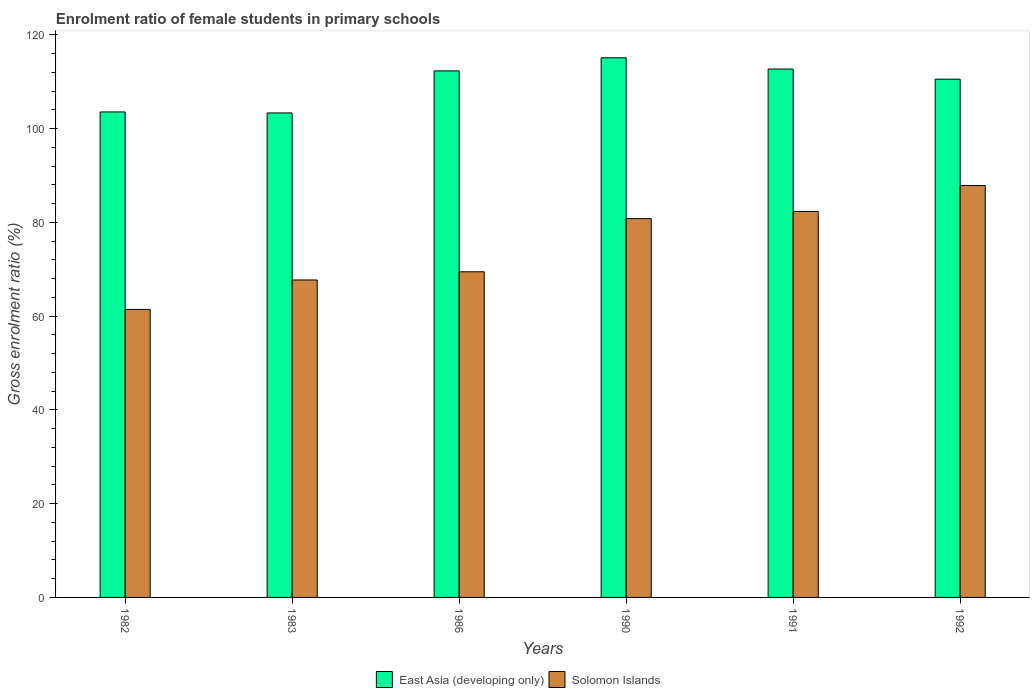How many different coloured bars are there?
Give a very brief answer. 2. How many groups of bars are there?
Make the answer very short. 6. How many bars are there on the 1st tick from the right?
Your response must be concise. 2. What is the label of the 6th group of bars from the left?
Make the answer very short. 1992. In how many cases, is the number of bars for a given year not equal to the number of legend labels?
Ensure brevity in your answer.  0. What is the enrolment ratio of female students in primary schools in East Asia (developing only) in 1992?
Give a very brief answer. 110.53. Across all years, what is the maximum enrolment ratio of female students in primary schools in Solomon Islands?
Provide a short and direct response. 87.85. Across all years, what is the minimum enrolment ratio of female students in primary schools in Solomon Islands?
Provide a short and direct response. 61.43. In which year was the enrolment ratio of female students in primary schools in East Asia (developing only) maximum?
Your answer should be very brief. 1990. In which year was the enrolment ratio of female students in primary schools in Solomon Islands minimum?
Your response must be concise. 1982. What is the total enrolment ratio of female students in primary schools in East Asia (developing only) in the graph?
Keep it short and to the point. 657.49. What is the difference between the enrolment ratio of female students in primary schools in East Asia (developing only) in 1986 and that in 1992?
Offer a terse response. 1.76. What is the difference between the enrolment ratio of female students in primary schools in East Asia (developing only) in 1982 and the enrolment ratio of female students in primary schools in Solomon Islands in 1983?
Ensure brevity in your answer.  35.84. What is the average enrolment ratio of female students in primary schools in East Asia (developing only) per year?
Make the answer very short. 109.58. In the year 1983, what is the difference between the enrolment ratio of female students in primary schools in East Asia (developing only) and enrolment ratio of female students in primary schools in Solomon Islands?
Your answer should be very brief. 35.63. What is the ratio of the enrolment ratio of female students in primary schools in Solomon Islands in 1990 to that in 1991?
Your response must be concise. 0.98. What is the difference between the highest and the second highest enrolment ratio of female students in primary schools in East Asia (developing only)?
Offer a terse response. 2.39. What is the difference between the highest and the lowest enrolment ratio of female students in primary schools in Solomon Islands?
Your answer should be compact. 26.43. In how many years, is the enrolment ratio of female students in primary schools in Solomon Islands greater than the average enrolment ratio of female students in primary schools in Solomon Islands taken over all years?
Your answer should be compact. 3. Is the sum of the enrolment ratio of female students in primary schools in Solomon Islands in 1982 and 1983 greater than the maximum enrolment ratio of female students in primary schools in East Asia (developing only) across all years?
Your answer should be very brief. Yes. What does the 2nd bar from the left in 1982 represents?
Ensure brevity in your answer.  Solomon Islands. What does the 2nd bar from the right in 1992 represents?
Your answer should be very brief. East Asia (developing only). How many bars are there?
Provide a short and direct response. 12. How many years are there in the graph?
Your answer should be very brief. 6. What is the difference between two consecutive major ticks on the Y-axis?
Your answer should be very brief. 20. What is the title of the graph?
Give a very brief answer. Enrolment ratio of female students in primary schools. Does "Afghanistan" appear as one of the legend labels in the graph?
Provide a short and direct response. No. What is the label or title of the Y-axis?
Provide a succinct answer. Gross enrolment ratio (%). What is the Gross enrolment ratio (%) of East Asia (developing only) in 1982?
Make the answer very short. 103.54. What is the Gross enrolment ratio (%) in Solomon Islands in 1982?
Your answer should be compact. 61.43. What is the Gross enrolment ratio (%) in East Asia (developing only) in 1983?
Offer a very short reply. 103.33. What is the Gross enrolment ratio (%) of Solomon Islands in 1983?
Offer a very short reply. 67.7. What is the Gross enrolment ratio (%) in East Asia (developing only) in 1986?
Give a very brief answer. 112.29. What is the Gross enrolment ratio (%) of Solomon Islands in 1986?
Provide a short and direct response. 69.45. What is the Gross enrolment ratio (%) of East Asia (developing only) in 1990?
Provide a succinct answer. 115.09. What is the Gross enrolment ratio (%) in Solomon Islands in 1990?
Make the answer very short. 80.79. What is the Gross enrolment ratio (%) in East Asia (developing only) in 1991?
Your response must be concise. 112.7. What is the Gross enrolment ratio (%) in Solomon Islands in 1991?
Give a very brief answer. 82.32. What is the Gross enrolment ratio (%) of East Asia (developing only) in 1992?
Give a very brief answer. 110.53. What is the Gross enrolment ratio (%) of Solomon Islands in 1992?
Provide a short and direct response. 87.85. Across all years, what is the maximum Gross enrolment ratio (%) in East Asia (developing only)?
Your answer should be very brief. 115.09. Across all years, what is the maximum Gross enrolment ratio (%) in Solomon Islands?
Your response must be concise. 87.85. Across all years, what is the minimum Gross enrolment ratio (%) in East Asia (developing only)?
Make the answer very short. 103.33. Across all years, what is the minimum Gross enrolment ratio (%) in Solomon Islands?
Make the answer very short. 61.43. What is the total Gross enrolment ratio (%) in East Asia (developing only) in the graph?
Offer a terse response. 657.49. What is the total Gross enrolment ratio (%) in Solomon Islands in the graph?
Your answer should be very brief. 449.55. What is the difference between the Gross enrolment ratio (%) of East Asia (developing only) in 1982 and that in 1983?
Provide a short and direct response. 0.21. What is the difference between the Gross enrolment ratio (%) of Solomon Islands in 1982 and that in 1983?
Offer a very short reply. -6.28. What is the difference between the Gross enrolment ratio (%) of East Asia (developing only) in 1982 and that in 1986?
Keep it short and to the point. -8.75. What is the difference between the Gross enrolment ratio (%) of Solomon Islands in 1982 and that in 1986?
Make the answer very short. -8.03. What is the difference between the Gross enrolment ratio (%) in East Asia (developing only) in 1982 and that in 1990?
Offer a terse response. -11.55. What is the difference between the Gross enrolment ratio (%) of Solomon Islands in 1982 and that in 1990?
Make the answer very short. -19.36. What is the difference between the Gross enrolment ratio (%) in East Asia (developing only) in 1982 and that in 1991?
Offer a terse response. -9.16. What is the difference between the Gross enrolment ratio (%) of Solomon Islands in 1982 and that in 1991?
Offer a terse response. -20.89. What is the difference between the Gross enrolment ratio (%) in East Asia (developing only) in 1982 and that in 1992?
Give a very brief answer. -6.99. What is the difference between the Gross enrolment ratio (%) in Solomon Islands in 1982 and that in 1992?
Provide a succinct answer. -26.43. What is the difference between the Gross enrolment ratio (%) in East Asia (developing only) in 1983 and that in 1986?
Provide a short and direct response. -8.96. What is the difference between the Gross enrolment ratio (%) in Solomon Islands in 1983 and that in 1986?
Ensure brevity in your answer.  -1.75. What is the difference between the Gross enrolment ratio (%) of East Asia (developing only) in 1983 and that in 1990?
Keep it short and to the point. -11.76. What is the difference between the Gross enrolment ratio (%) of Solomon Islands in 1983 and that in 1990?
Offer a very short reply. -13.09. What is the difference between the Gross enrolment ratio (%) in East Asia (developing only) in 1983 and that in 1991?
Provide a short and direct response. -9.37. What is the difference between the Gross enrolment ratio (%) of Solomon Islands in 1983 and that in 1991?
Give a very brief answer. -14.62. What is the difference between the Gross enrolment ratio (%) in East Asia (developing only) in 1983 and that in 1992?
Provide a succinct answer. -7.2. What is the difference between the Gross enrolment ratio (%) of Solomon Islands in 1983 and that in 1992?
Offer a very short reply. -20.15. What is the difference between the Gross enrolment ratio (%) of East Asia (developing only) in 1986 and that in 1990?
Offer a very short reply. -2.8. What is the difference between the Gross enrolment ratio (%) in Solomon Islands in 1986 and that in 1990?
Make the answer very short. -11.34. What is the difference between the Gross enrolment ratio (%) of East Asia (developing only) in 1986 and that in 1991?
Provide a succinct answer. -0.41. What is the difference between the Gross enrolment ratio (%) in Solomon Islands in 1986 and that in 1991?
Provide a short and direct response. -12.87. What is the difference between the Gross enrolment ratio (%) in East Asia (developing only) in 1986 and that in 1992?
Offer a very short reply. 1.76. What is the difference between the Gross enrolment ratio (%) in Solomon Islands in 1986 and that in 1992?
Provide a succinct answer. -18.4. What is the difference between the Gross enrolment ratio (%) of East Asia (developing only) in 1990 and that in 1991?
Make the answer very short. 2.39. What is the difference between the Gross enrolment ratio (%) of Solomon Islands in 1990 and that in 1991?
Your answer should be very brief. -1.53. What is the difference between the Gross enrolment ratio (%) of East Asia (developing only) in 1990 and that in 1992?
Give a very brief answer. 4.55. What is the difference between the Gross enrolment ratio (%) of Solomon Islands in 1990 and that in 1992?
Keep it short and to the point. -7.06. What is the difference between the Gross enrolment ratio (%) of East Asia (developing only) in 1991 and that in 1992?
Offer a very short reply. 2.16. What is the difference between the Gross enrolment ratio (%) of Solomon Islands in 1991 and that in 1992?
Offer a terse response. -5.53. What is the difference between the Gross enrolment ratio (%) of East Asia (developing only) in 1982 and the Gross enrolment ratio (%) of Solomon Islands in 1983?
Offer a terse response. 35.84. What is the difference between the Gross enrolment ratio (%) in East Asia (developing only) in 1982 and the Gross enrolment ratio (%) in Solomon Islands in 1986?
Give a very brief answer. 34.09. What is the difference between the Gross enrolment ratio (%) in East Asia (developing only) in 1982 and the Gross enrolment ratio (%) in Solomon Islands in 1990?
Offer a terse response. 22.75. What is the difference between the Gross enrolment ratio (%) of East Asia (developing only) in 1982 and the Gross enrolment ratio (%) of Solomon Islands in 1991?
Keep it short and to the point. 21.22. What is the difference between the Gross enrolment ratio (%) of East Asia (developing only) in 1982 and the Gross enrolment ratio (%) of Solomon Islands in 1992?
Give a very brief answer. 15.69. What is the difference between the Gross enrolment ratio (%) in East Asia (developing only) in 1983 and the Gross enrolment ratio (%) in Solomon Islands in 1986?
Make the answer very short. 33.88. What is the difference between the Gross enrolment ratio (%) in East Asia (developing only) in 1983 and the Gross enrolment ratio (%) in Solomon Islands in 1990?
Offer a very short reply. 22.54. What is the difference between the Gross enrolment ratio (%) of East Asia (developing only) in 1983 and the Gross enrolment ratio (%) of Solomon Islands in 1991?
Provide a succinct answer. 21.01. What is the difference between the Gross enrolment ratio (%) of East Asia (developing only) in 1983 and the Gross enrolment ratio (%) of Solomon Islands in 1992?
Provide a short and direct response. 15.48. What is the difference between the Gross enrolment ratio (%) in East Asia (developing only) in 1986 and the Gross enrolment ratio (%) in Solomon Islands in 1990?
Ensure brevity in your answer.  31.5. What is the difference between the Gross enrolment ratio (%) of East Asia (developing only) in 1986 and the Gross enrolment ratio (%) of Solomon Islands in 1991?
Your answer should be compact. 29.97. What is the difference between the Gross enrolment ratio (%) in East Asia (developing only) in 1986 and the Gross enrolment ratio (%) in Solomon Islands in 1992?
Your answer should be very brief. 24.44. What is the difference between the Gross enrolment ratio (%) of East Asia (developing only) in 1990 and the Gross enrolment ratio (%) of Solomon Islands in 1991?
Your answer should be compact. 32.77. What is the difference between the Gross enrolment ratio (%) in East Asia (developing only) in 1990 and the Gross enrolment ratio (%) in Solomon Islands in 1992?
Make the answer very short. 27.23. What is the difference between the Gross enrolment ratio (%) of East Asia (developing only) in 1991 and the Gross enrolment ratio (%) of Solomon Islands in 1992?
Provide a short and direct response. 24.84. What is the average Gross enrolment ratio (%) of East Asia (developing only) per year?
Your response must be concise. 109.58. What is the average Gross enrolment ratio (%) in Solomon Islands per year?
Offer a very short reply. 74.93. In the year 1982, what is the difference between the Gross enrolment ratio (%) of East Asia (developing only) and Gross enrolment ratio (%) of Solomon Islands?
Your answer should be very brief. 42.11. In the year 1983, what is the difference between the Gross enrolment ratio (%) in East Asia (developing only) and Gross enrolment ratio (%) in Solomon Islands?
Keep it short and to the point. 35.63. In the year 1986, what is the difference between the Gross enrolment ratio (%) in East Asia (developing only) and Gross enrolment ratio (%) in Solomon Islands?
Provide a short and direct response. 42.84. In the year 1990, what is the difference between the Gross enrolment ratio (%) of East Asia (developing only) and Gross enrolment ratio (%) of Solomon Islands?
Keep it short and to the point. 34.3. In the year 1991, what is the difference between the Gross enrolment ratio (%) of East Asia (developing only) and Gross enrolment ratio (%) of Solomon Islands?
Ensure brevity in your answer.  30.38. In the year 1992, what is the difference between the Gross enrolment ratio (%) in East Asia (developing only) and Gross enrolment ratio (%) in Solomon Islands?
Offer a very short reply. 22.68. What is the ratio of the Gross enrolment ratio (%) of Solomon Islands in 1982 to that in 1983?
Your response must be concise. 0.91. What is the ratio of the Gross enrolment ratio (%) in East Asia (developing only) in 1982 to that in 1986?
Offer a terse response. 0.92. What is the ratio of the Gross enrolment ratio (%) in Solomon Islands in 1982 to that in 1986?
Ensure brevity in your answer.  0.88. What is the ratio of the Gross enrolment ratio (%) in East Asia (developing only) in 1982 to that in 1990?
Provide a short and direct response. 0.9. What is the ratio of the Gross enrolment ratio (%) in Solomon Islands in 1982 to that in 1990?
Your answer should be compact. 0.76. What is the ratio of the Gross enrolment ratio (%) of East Asia (developing only) in 1982 to that in 1991?
Keep it short and to the point. 0.92. What is the ratio of the Gross enrolment ratio (%) in Solomon Islands in 1982 to that in 1991?
Your answer should be compact. 0.75. What is the ratio of the Gross enrolment ratio (%) of East Asia (developing only) in 1982 to that in 1992?
Provide a short and direct response. 0.94. What is the ratio of the Gross enrolment ratio (%) of Solomon Islands in 1982 to that in 1992?
Ensure brevity in your answer.  0.7. What is the ratio of the Gross enrolment ratio (%) of East Asia (developing only) in 1983 to that in 1986?
Your answer should be compact. 0.92. What is the ratio of the Gross enrolment ratio (%) in Solomon Islands in 1983 to that in 1986?
Your answer should be very brief. 0.97. What is the ratio of the Gross enrolment ratio (%) in East Asia (developing only) in 1983 to that in 1990?
Offer a terse response. 0.9. What is the ratio of the Gross enrolment ratio (%) in Solomon Islands in 1983 to that in 1990?
Provide a succinct answer. 0.84. What is the ratio of the Gross enrolment ratio (%) in East Asia (developing only) in 1983 to that in 1991?
Make the answer very short. 0.92. What is the ratio of the Gross enrolment ratio (%) of Solomon Islands in 1983 to that in 1991?
Your answer should be very brief. 0.82. What is the ratio of the Gross enrolment ratio (%) of East Asia (developing only) in 1983 to that in 1992?
Your answer should be very brief. 0.93. What is the ratio of the Gross enrolment ratio (%) of Solomon Islands in 1983 to that in 1992?
Give a very brief answer. 0.77. What is the ratio of the Gross enrolment ratio (%) of East Asia (developing only) in 1986 to that in 1990?
Offer a terse response. 0.98. What is the ratio of the Gross enrolment ratio (%) of Solomon Islands in 1986 to that in 1990?
Your answer should be compact. 0.86. What is the ratio of the Gross enrolment ratio (%) in East Asia (developing only) in 1986 to that in 1991?
Offer a very short reply. 1. What is the ratio of the Gross enrolment ratio (%) of Solomon Islands in 1986 to that in 1991?
Offer a terse response. 0.84. What is the ratio of the Gross enrolment ratio (%) in East Asia (developing only) in 1986 to that in 1992?
Ensure brevity in your answer.  1.02. What is the ratio of the Gross enrolment ratio (%) of Solomon Islands in 1986 to that in 1992?
Your response must be concise. 0.79. What is the ratio of the Gross enrolment ratio (%) in East Asia (developing only) in 1990 to that in 1991?
Ensure brevity in your answer.  1.02. What is the ratio of the Gross enrolment ratio (%) in Solomon Islands in 1990 to that in 1991?
Give a very brief answer. 0.98. What is the ratio of the Gross enrolment ratio (%) in East Asia (developing only) in 1990 to that in 1992?
Give a very brief answer. 1.04. What is the ratio of the Gross enrolment ratio (%) in Solomon Islands in 1990 to that in 1992?
Offer a terse response. 0.92. What is the ratio of the Gross enrolment ratio (%) in East Asia (developing only) in 1991 to that in 1992?
Give a very brief answer. 1.02. What is the ratio of the Gross enrolment ratio (%) of Solomon Islands in 1991 to that in 1992?
Provide a succinct answer. 0.94. What is the difference between the highest and the second highest Gross enrolment ratio (%) in East Asia (developing only)?
Provide a succinct answer. 2.39. What is the difference between the highest and the second highest Gross enrolment ratio (%) in Solomon Islands?
Ensure brevity in your answer.  5.53. What is the difference between the highest and the lowest Gross enrolment ratio (%) of East Asia (developing only)?
Offer a terse response. 11.76. What is the difference between the highest and the lowest Gross enrolment ratio (%) in Solomon Islands?
Make the answer very short. 26.43. 